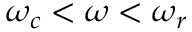Convert formula to latex. <formula><loc_0><loc_0><loc_500><loc_500>\omega _ { c } < \omega < \omega _ { r }</formula> 